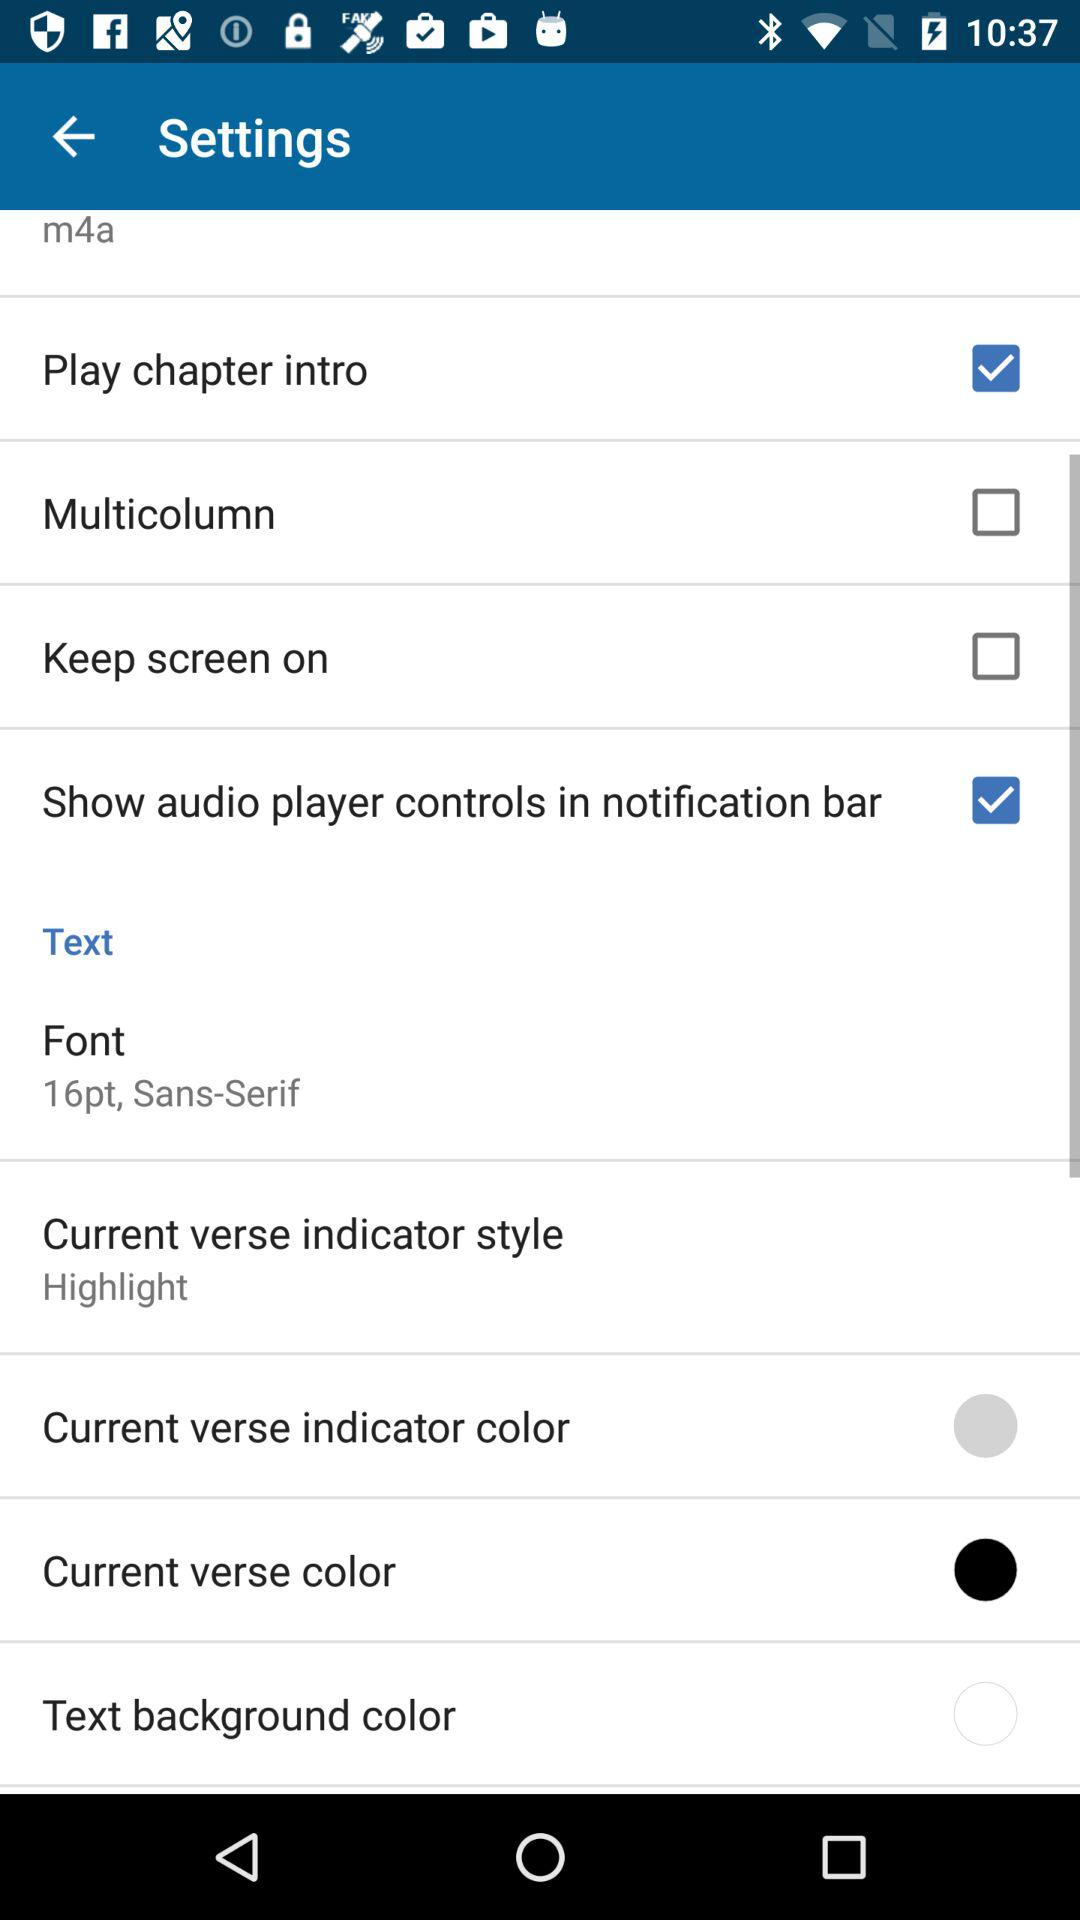How many settings have checkbox options?
Answer the question using a single word or phrase. 4 